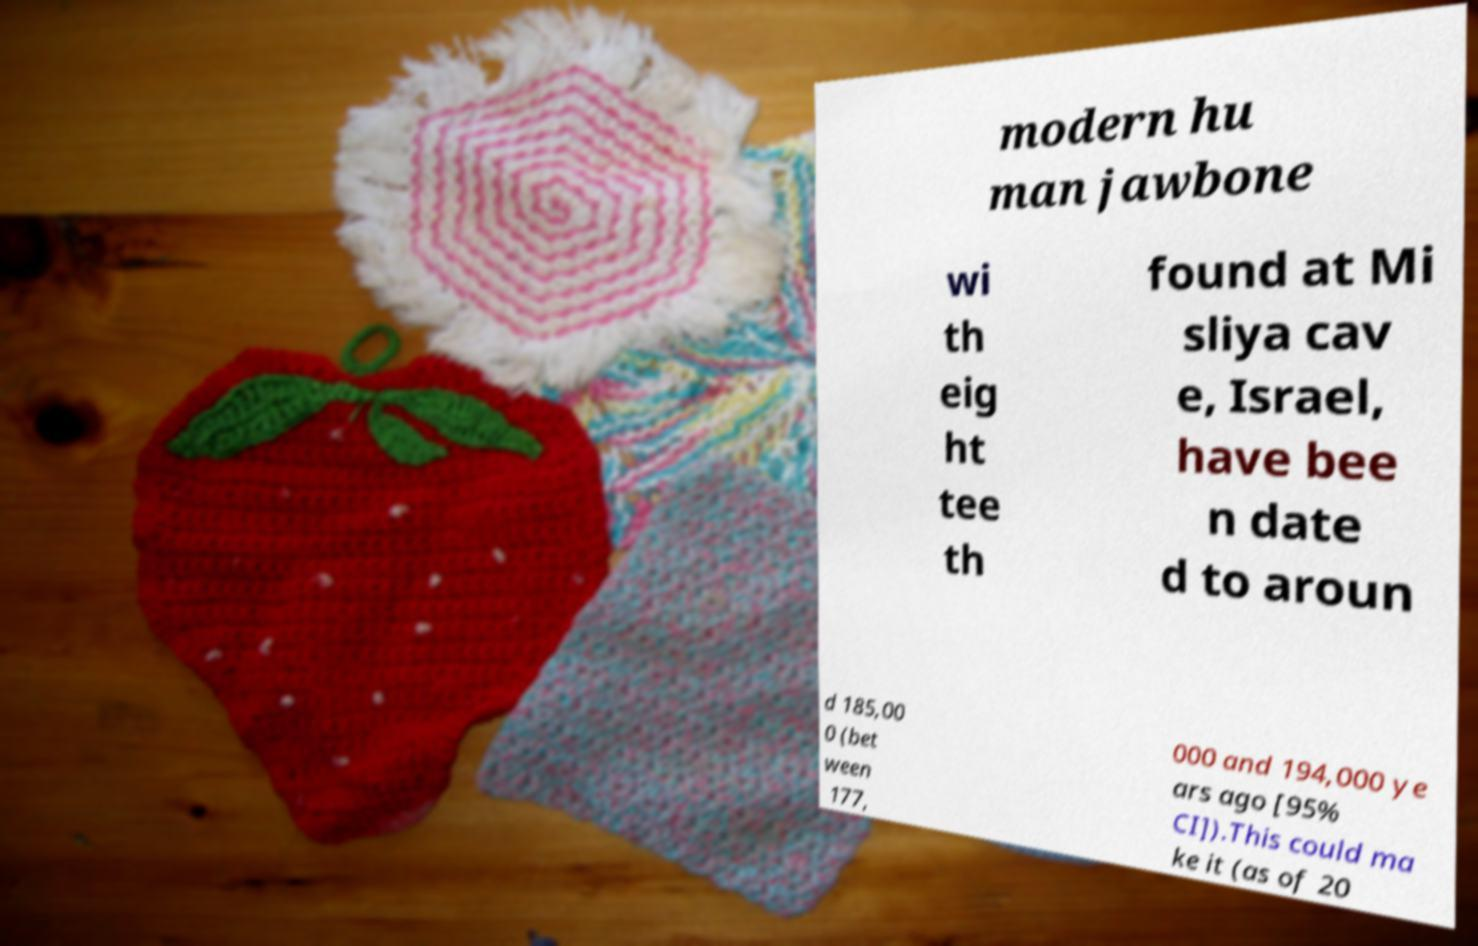Could you assist in decoding the text presented in this image and type it out clearly? modern hu man jawbone wi th eig ht tee th found at Mi sliya cav e, Israel, have bee n date d to aroun d 185,00 0 (bet ween 177, 000 and 194,000 ye ars ago [95% CI]).This could ma ke it (as of 20 